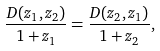<formula> <loc_0><loc_0><loc_500><loc_500>\frac { D ( z _ { 1 } , z _ { 2 } ) } { 1 + z _ { 1 } } = \frac { D ( z _ { 2 } , z _ { 1 } ) } { 1 + z _ { 2 } } ,</formula> 